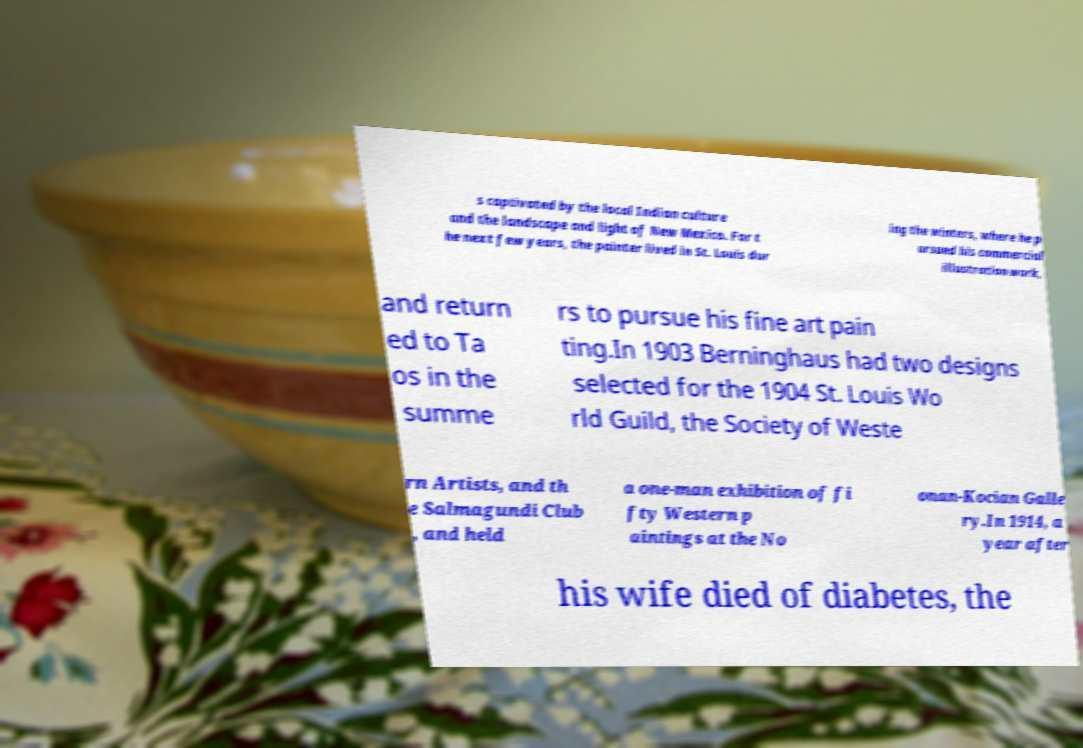I need the written content from this picture converted into text. Can you do that? s captivated by the local Indian culture and the landscape and light of New Mexico. For t he next few years, the painter lived in St. Louis dur ing the winters, where he p ursued his commercial illustration work, and return ed to Ta os in the summe rs to pursue his fine art pain ting.In 1903 Berninghaus had two designs selected for the 1904 St. Louis Wo rld Guild, the Society of Weste rn Artists, and th e Salmagundi Club , and held a one-man exhibition of fi fty Western p aintings at the No onan-Kocian Galle ry.In 1914, a year after his wife died of diabetes, the 